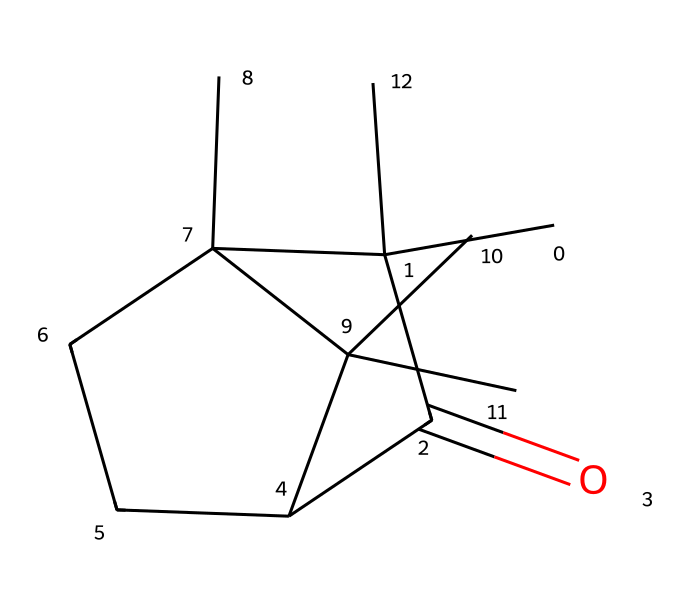What is the molecular formula of camphor? To determine the molecular formula from the SMILES representation, we identify the number of each type of atom present. The structure indicates that there are 10 carbon atoms (C), 16 hydrogen atoms (H), and 1 oxygen atom (O). Therefore, the molecular formula is C10H16O.
Answer: C10H16O How many stereocenters are present in camphor? By examining the structure derived from the SMILES, we look for carbon atoms that are attached to four different groups. This characterizes them as stereocenters. In the case of camphor, there are two carbons fulfilling this condition, indicating that there are two stereocenters in the molecule.
Answer: 2 What type of compound is camphor classified as? Camphor has a molecular structure that indicates it is primarily derived from terpenes, characterized by its cyclic structure and functional groups. It is classified as a bicyclic monoterpene due to its two linked rings formed from the 10 carbon atoms.
Answer: bicyclic monoterpene What functional group is present in camphor? Looking closely at the molecular structure, we identify the presence of a carbonyl group (C=O), which indicates a ketone functional group in camphor. This is a key feature for identifying its chemical properties.
Answer: ketone How many rings are present in the camphor structure? From analyzing the structure, we can see that camphor consists of two interconnected cycloalkane rings, making it a bicyclic structure. This is a significant aspect of its characterization as a terpenoid.
Answer: 2 What type of interaction is camphor likely to favor due to its structure? Considering the presence of the polar carbonyl group and the hydrophobic hydrocarbon portions, camphor is likely to favor dipole-dipole interactions with other polar molecules while also exhibiting hydrophobic interactions with nonpolar environments.
Answer: dipole-dipole interactions 